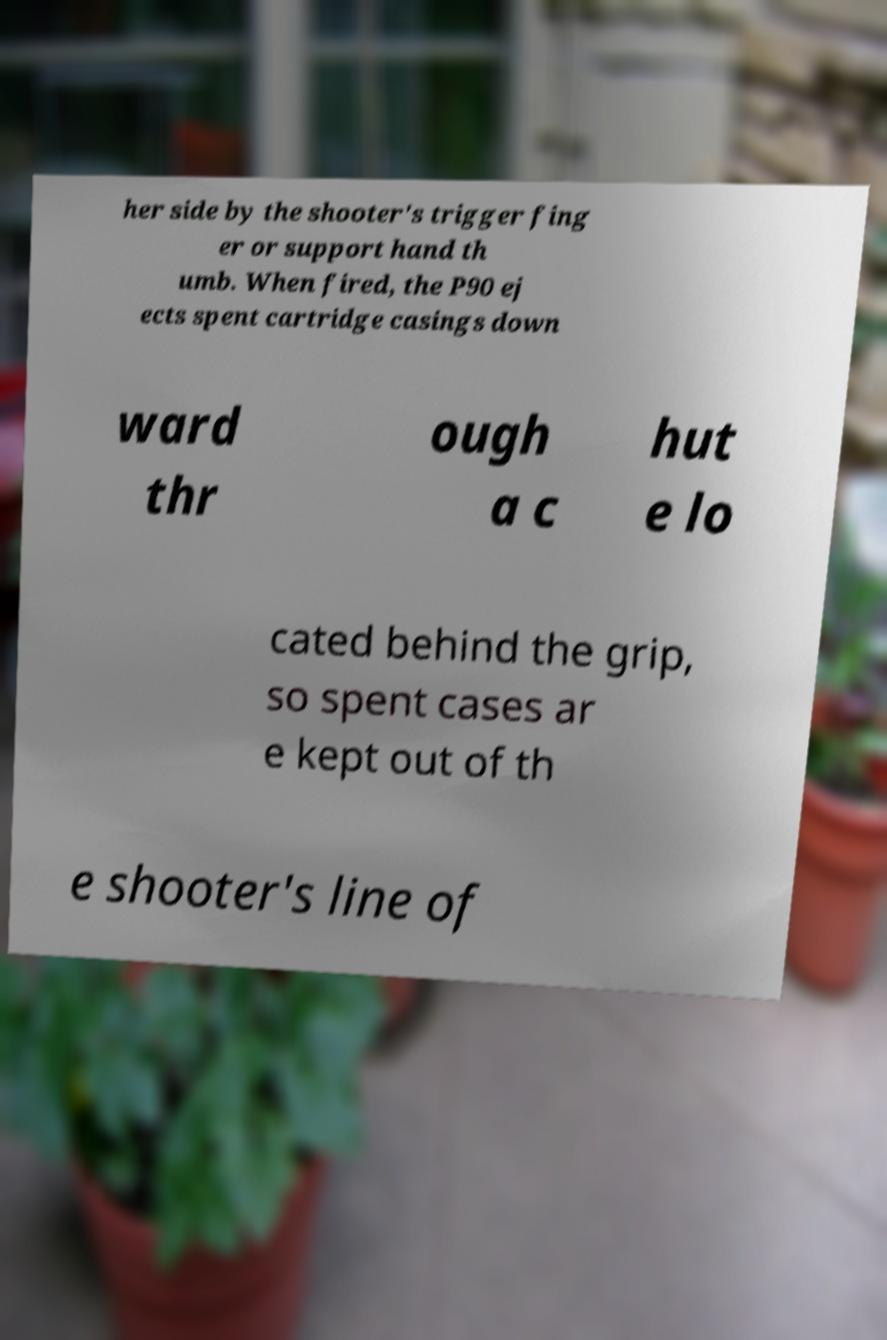Please read and relay the text visible in this image. What does it say? her side by the shooter's trigger fing er or support hand th umb. When fired, the P90 ej ects spent cartridge casings down ward thr ough a c hut e lo cated behind the grip, so spent cases ar e kept out of th e shooter's line of 